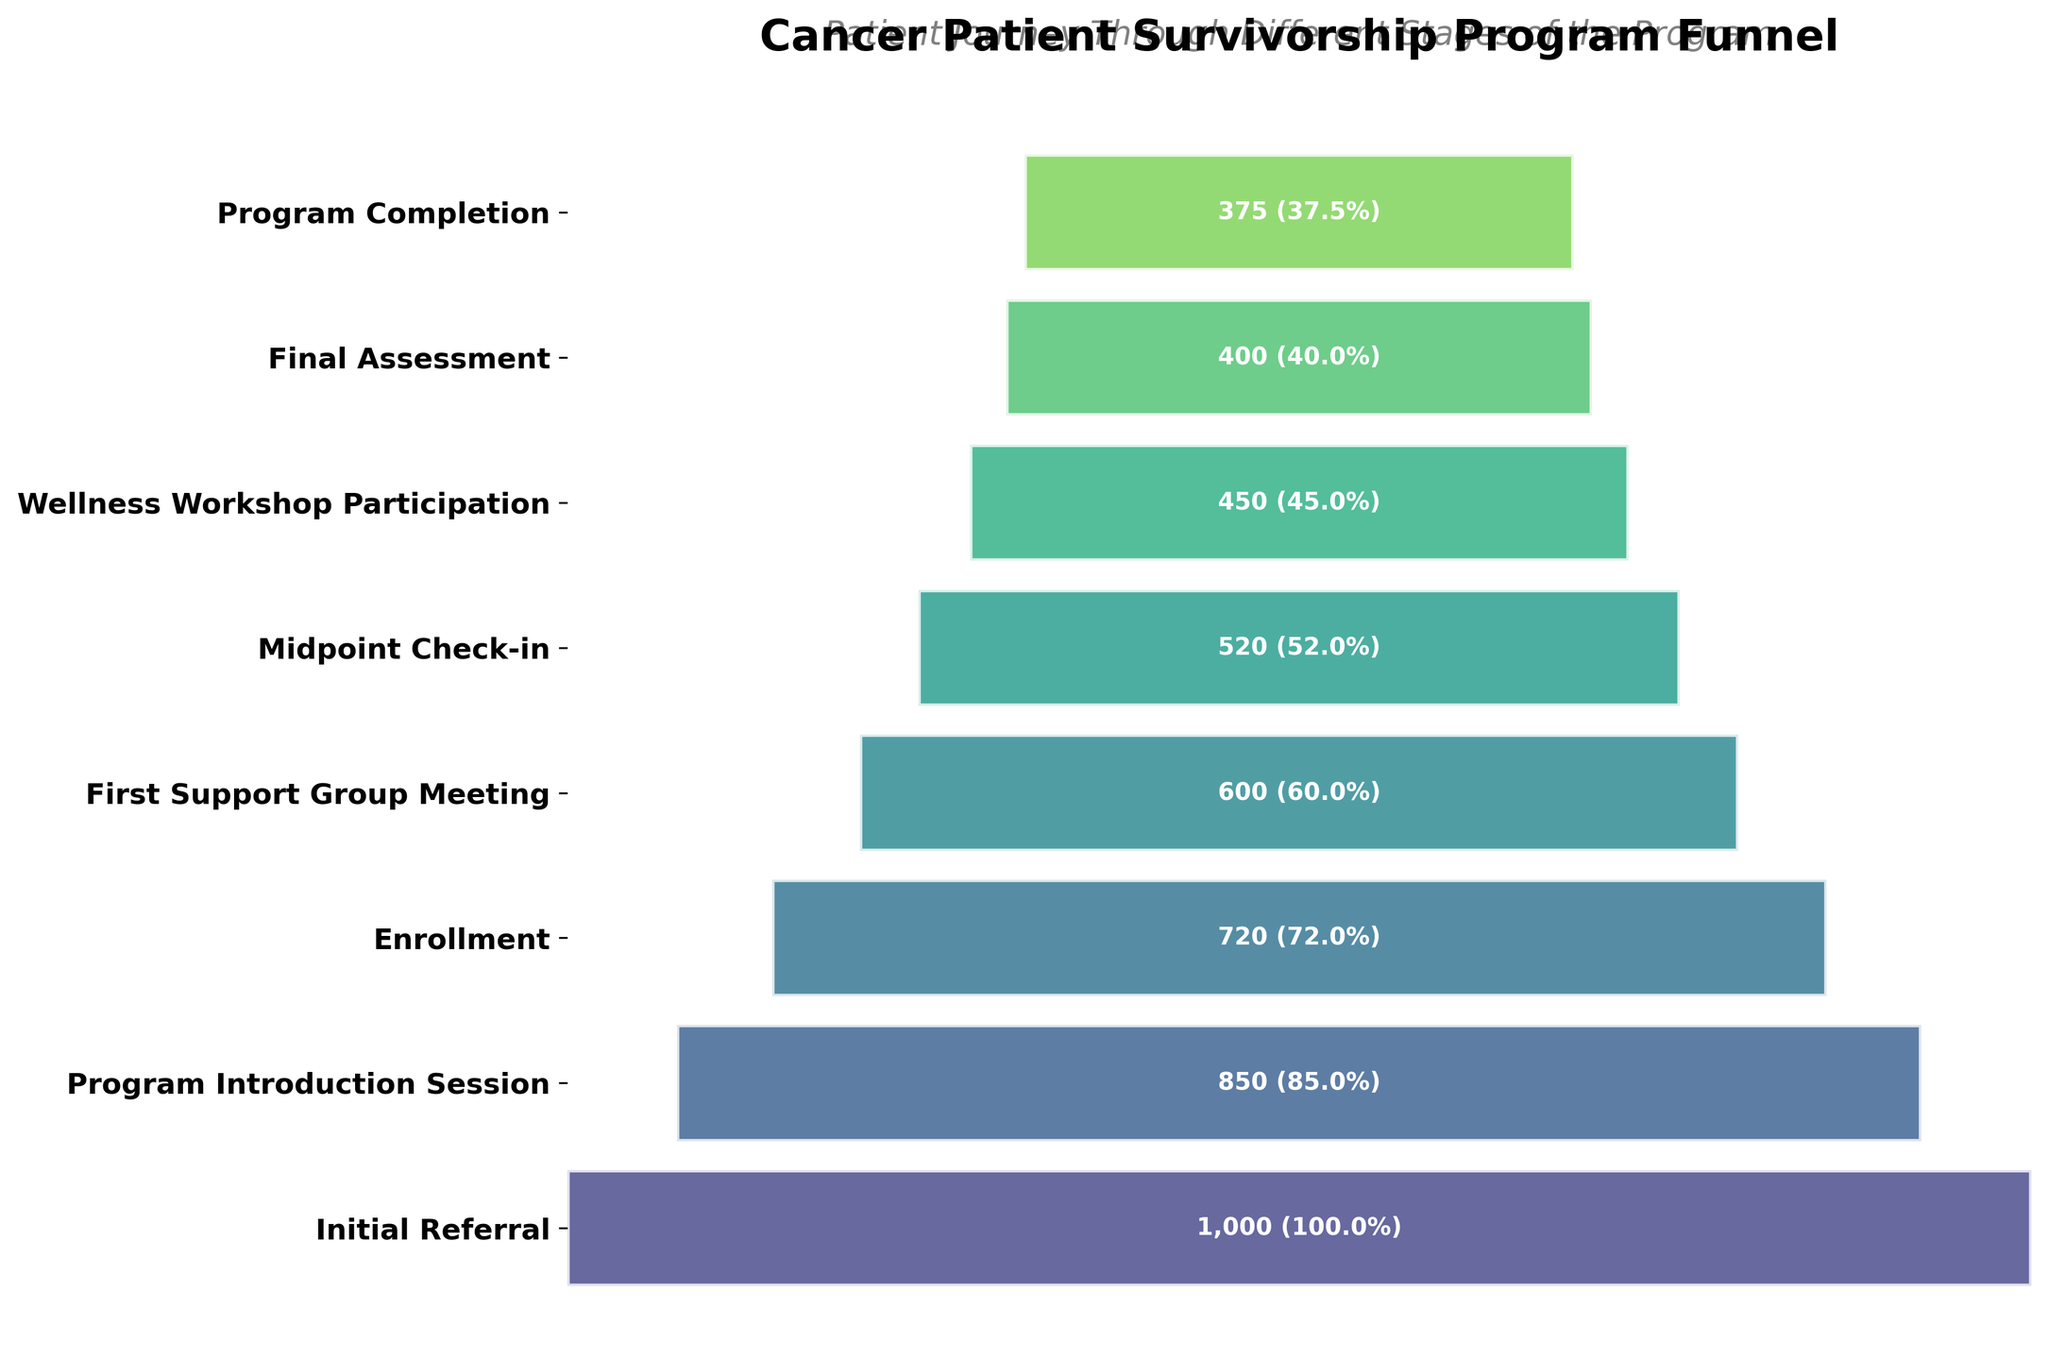What is the title of the Funnel Chart? The figure title is positioned at the top and reads "Cancer Patient Survivorship Program Funnel".
Answer: Cancer Patient Survivorship Program Funnel How many stages are there in the program? The Funnel Chart displays each stage from top to bottom. Counting them gives us the total number of stages.
Answer: 8 At which stage does the number of patients first drop below 500? By looking at the patient count annotations on each bar, we can see that the stage "Midpoint Check-in" has 520 patients, but the next stage "Wellness Workshop Participation" has 450 patients.
Answer: Wellness Workshop Participation What percentage of patients complete the program? The Funnel Chart lists the patient count for each stage. The final stage "Program Completion" shows 375 patients out of the initial 1000 referred. To find the percentage: (375/1000) * 100 = 37.5%.
Answer: 37.5% How many patients proceed from the "Enrollment" stage to the "First Support Group Meeting" stage, and what is the difference? The bar labeled "Enrollment" has 720 patients and the "First Support Group Meeting" has 600. The difference is 720 - 600 = 120 patients.
Answer: 120 What is the biggest drop in number of patients between two consecutive stages? By examining the patient count differences between every consecutive stage, the largest drop occurs from "Program Introduction Session" (850) to "Enrollment" (720). The difference here is 850 - 720 = 130.
Answer: 130 How many patients do not complete the program after the final assessment? The final assessment stage has 400 patients, while the program completion has 375. The difference is 400 - 375 = 25 patients.
Answer: 25 What is the average number of patients for all stages? To find the average, sum all the patient counts across stages and divide by the number of stages: (1000 + 850 + 720 + 600 + 520 + 450 + 400 + 375) / 8 = 4915 / 8 = 614.375.
Answer: 614.375 From which stage to which stage is the highest percentage of patients lost? Calculate the percentage loss between each stage by comparing the counts, then identifying the largest percentage drop: For "Program Introduction Session" to "Enrollment": ((850 - 720) / 850) * 100 = 15.3%. This is the highest percentage drop.
Answer: Program Introduction Session to Enrollment 